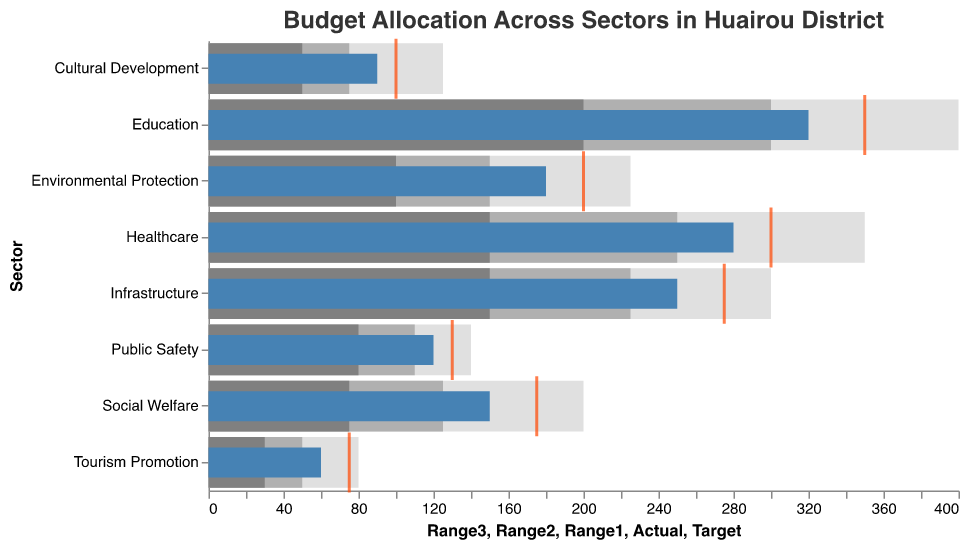What is the title of the chart? The title is displayed at the top of the chart and provides a summary of what the chart is about.
Answer: Budget Allocation Across Sectors in Huairou District Which sector has the highest actual budget allocation? Look for the longest bar colored in blue, which represents the actual budget allocation.
Answer: Education Is the actual budget for the Healthcare sector above or below its target? Compare the position of the blue bar for Healthcare to the red tick, which represents the target.
Answer: Below Which two sectors have the smallest difference between their actual and target budgets? Calculate the absolute difference between the actual (blue bar) and target (red tick) for each sector and identify the two smallest differences.
Answer: Healthcare and Public Safety How does the actual budget for Environmental Protection compare to its minimal range value? Compare the blue bar (actual budget) for Environmental Protection to the start of the gray bars (minimal range).
Answer: Above What is the average target budget across all sectors? Sum all target values and divide by the number of sectors (8). Average = (350+300+275+200+175+100+130+75) / 8 = 200.
Answer: 200 Which sector's actual budget allocation most exceeds its minimal range? For each sector, subtract the minimal range value from the actual budget and identify the highest result.
Answer: Healthcare How many sectors have an actual budget allocation within their respective good ranges (second gray bar)? Count the sectors where the blue bar (actual) falls within the second gray bar range.
Answer: 4 (Education, Infrastructure, Environmental Protection, Public Safety) Which sector has the smallest actual budget allocation and what is its actual budget? Look for the shortest blue bar and read its value.
Answer: Tourism Promotion, 60 